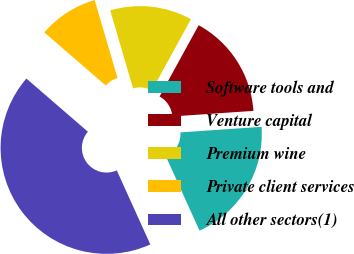<chart> <loc_0><loc_0><loc_500><loc_500><pie_chart><fcel>Software tools and<fcel>Venture capital<fcel>Premium wine<fcel>Private client services<fcel>All other sectors(1)<nl><fcel>19.32%<fcel>15.92%<fcel>12.52%<fcel>9.12%<fcel>43.11%<nl></chart> 